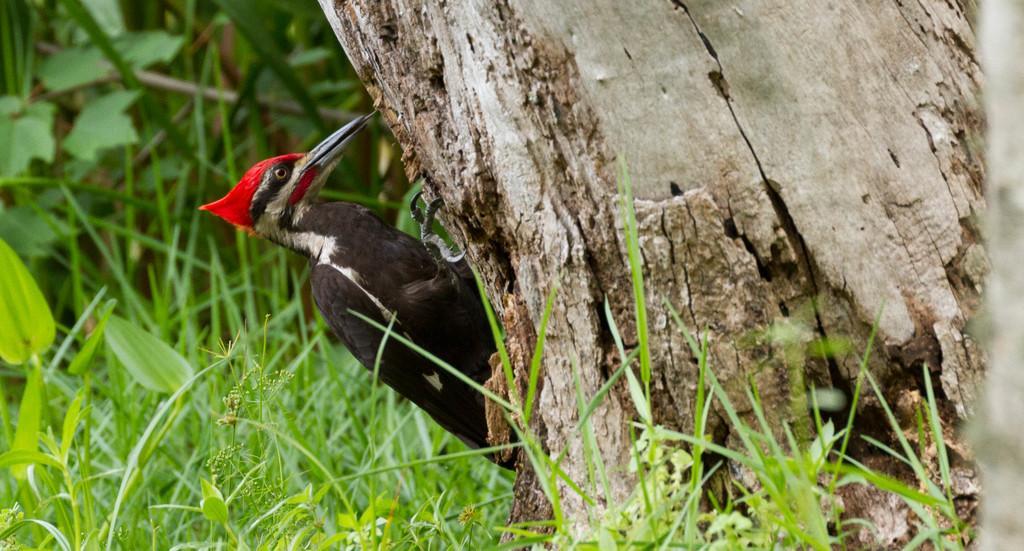Can you describe this image briefly? In this image we can see a woodpecker on the a truncated tree. At the bottom we can see plants and grass on the ground. On the left side there are plants on the ground. 